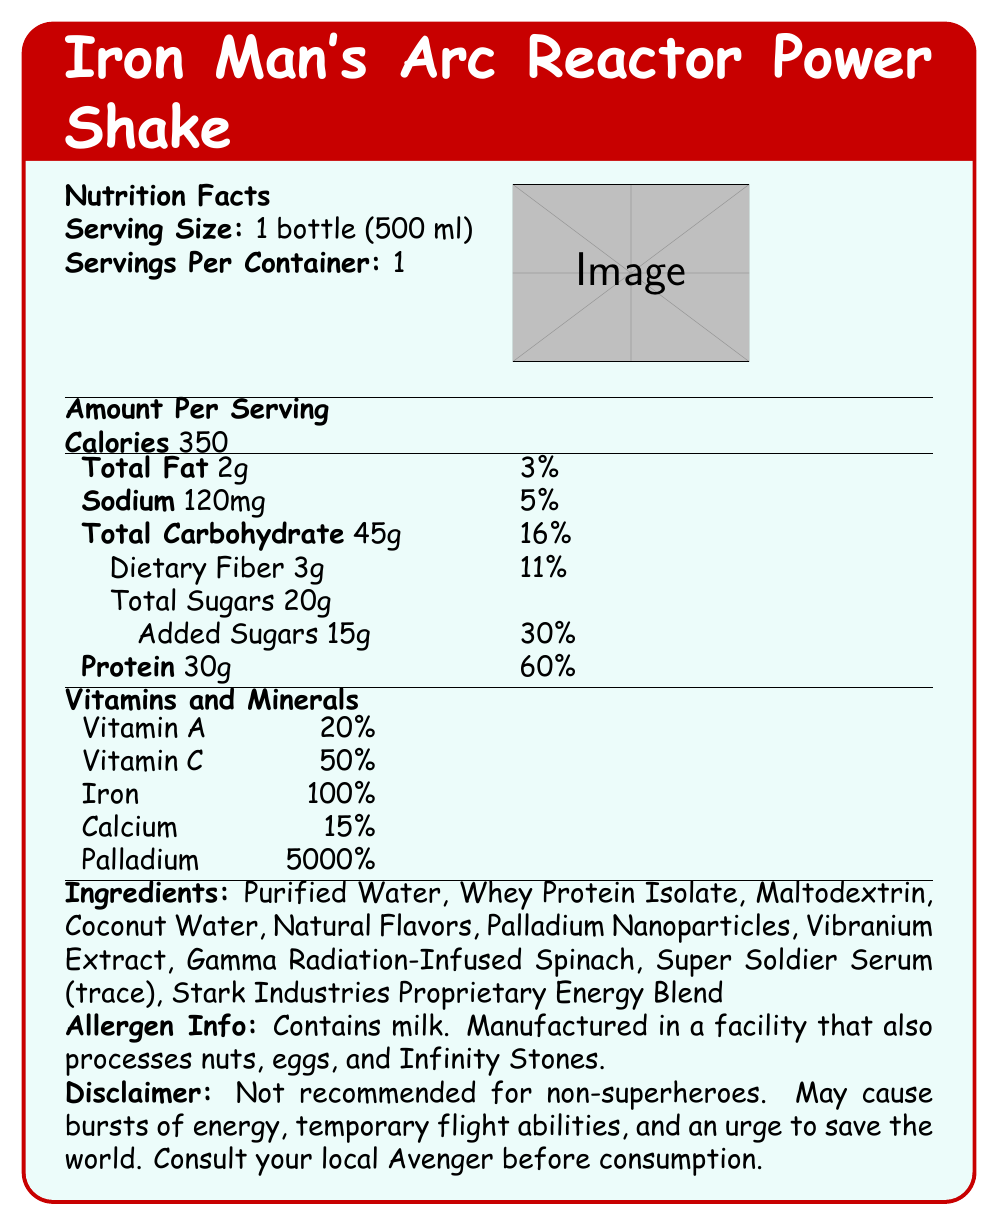what is the serving size for Iron Man's Arc Reactor Power Shake? The serving size is indicated as "1 bottle (500 ml)" under the nutrition facts section.
Answer: 1 bottle (500 ml) how many calories does one serving of Iron Man's Arc Reactor Power Shake contain? The document states "Calories 350" under the amount per serving section.
Answer: 350 what percentage of the daily value of sodium does one serving provide? The sodium section lists "5%" as the daily value percentage.
Answer: 5% what ingredient is listed immediately after "Coconut Water" in the ingredients list? In the ingredients list, "Natural Flavors" comes directly after "Coconut Water".
Answer: Natural Flavors how much protein is in one serving of the shake? The document states "Protein 30g" in the nutrition facts section.
Answer: 30g which vitamin has the highest daily value percentage in the shake? A. Vitamin A B. Vitamin C C. Calcium D. Iron Iron has a daily value percentage of "100%", which is the highest among the listed vitamins.
Answer: D. Iron what unique ingredient in the shake has an incredibly high daily value percentage, far beyond typical nutritional needs? A. Vitamin A B. Vitamin C C. Palladium D. Iron The daily value percentage for Palladium is listed as "5000%", which is extraordinarily high compared to other nutrients.
Answer: C. Palladium does Iron Man's Arc Reactor Power Shake contain added sugars? The document states "Added Sugars 15g" under the sugars section.
Answer: Yes summary question: what is the main purpose of the document? The document presents the nutrition facts, serving size, calories, ingredients, allergen info, and a disclaimer for the product. It includes data on macronutrients, vitamins, minerals, and specific ingredients, aiming to inform consumers about the nutritional contents of the shake.
Answer: To provide detailed nutrition information and ingredient list for Iron Man's Arc Reactor Power Shake. can a regular person safely consume Iron Man's Arc Reactor Power Shake? The disclaimer clearly states "Not recommended for non-superheroes" and mentions potential effects like bursts of energy, temporary flight abilities, and the urge to save the world.
Answer: No is there any information about the quantities of Vibranium Extract in the shake? The ingredients list mentions "Vibranium Extract," but the document does not provide the specific quantity of this ingredient.
Answer: Not enough information 